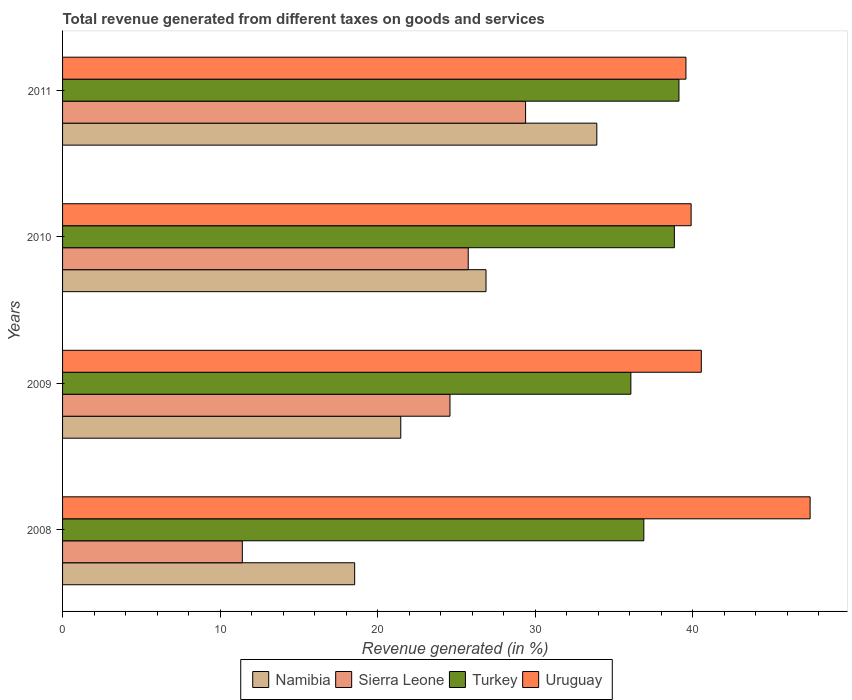How many groups of bars are there?
Make the answer very short. 4. Are the number of bars per tick equal to the number of legend labels?
Give a very brief answer. Yes. How many bars are there on the 3rd tick from the bottom?
Your answer should be very brief. 4. What is the label of the 3rd group of bars from the top?
Your answer should be very brief. 2009. In how many cases, is the number of bars for a given year not equal to the number of legend labels?
Provide a short and direct response. 0. What is the total revenue generated in Turkey in 2011?
Ensure brevity in your answer.  39.13. Across all years, what is the maximum total revenue generated in Uruguay?
Provide a succinct answer. 47.45. Across all years, what is the minimum total revenue generated in Sierra Leone?
Ensure brevity in your answer.  11.41. In which year was the total revenue generated in Sierra Leone minimum?
Your answer should be very brief. 2008. What is the total total revenue generated in Turkey in the graph?
Make the answer very short. 150.93. What is the difference between the total revenue generated in Sierra Leone in 2008 and that in 2010?
Keep it short and to the point. -14.34. What is the difference between the total revenue generated in Turkey in 2011 and the total revenue generated in Sierra Leone in 2008?
Your answer should be compact. 27.72. What is the average total revenue generated in Namibia per year?
Offer a very short reply. 25.2. In the year 2010, what is the difference between the total revenue generated in Sierra Leone and total revenue generated in Turkey?
Offer a terse response. -13.08. What is the ratio of the total revenue generated in Namibia in 2008 to that in 2011?
Provide a short and direct response. 0.55. Is the difference between the total revenue generated in Sierra Leone in 2009 and 2011 greater than the difference between the total revenue generated in Turkey in 2009 and 2011?
Make the answer very short. No. What is the difference between the highest and the second highest total revenue generated in Turkey?
Your response must be concise. 0.29. What is the difference between the highest and the lowest total revenue generated in Namibia?
Ensure brevity in your answer.  15.37. In how many years, is the total revenue generated in Turkey greater than the average total revenue generated in Turkey taken over all years?
Provide a short and direct response. 2. Is the sum of the total revenue generated in Uruguay in 2010 and 2011 greater than the maximum total revenue generated in Sierra Leone across all years?
Offer a very short reply. Yes. Is it the case that in every year, the sum of the total revenue generated in Uruguay and total revenue generated in Sierra Leone is greater than the sum of total revenue generated in Turkey and total revenue generated in Namibia?
Provide a succinct answer. No. What does the 1st bar from the top in 2010 represents?
Give a very brief answer. Uruguay. What does the 1st bar from the bottom in 2010 represents?
Your response must be concise. Namibia. Is it the case that in every year, the sum of the total revenue generated in Uruguay and total revenue generated in Namibia is greater than the total revenue generated in Sierra Leone?
Give a very brief answer. Yes. What is the difference between two consecutive major ticks on the X-axis?
Your answer should be compact. 10. Does the graph contain any zero values?
Offer a terse response. No. Does the graph contain grids?
Your answer should be compact. No. Where does the legend appear in the graph?
Make the answer very short. Bottom center. How many legend labels are there?
Provide a short and direct response. 4. How are the legend labels stacked?
Your response must be concise. Horizontal. What is the title of the graph?
Provide a short and direct response. Total revenue generated from different taxes on goods and services. Does "Aruba" appear as one of the legend labels in the graph?
Your answer should be compact. No. What is the label or title of the X-axis?
Provide a succinct answer. Revenue generated (in %). What is the Revenue generated (in %) in Namibia in 2008?
Make the answer very short. 18.54. What is the Revenue generated (in %) of Sierra Leone in 2008?
Your response must be concise. 11.41. What is the Revenue generated (in %) of Turkey in 2008?
Your response must be concise. 36.9. What is the Revenue generated (in %) of Uruguay in 2008?
Give a very brief answer. 47.45. What is the Revenue generated (in %) in Namibia in 2009?
Offer a terse response. 21.47. What is the Revenue generated (in %) in Sierra Leone in 2009?
Make the answer very short. 24.59. What is the Revenue generated (in %) of Turkey in 2009?
Ensure brevity in your answer.  36.07. What is the Revenue generated (in %) of Uruguay in 2009?
Offer a terse response. 40.55. What is the Revenue generated (in %) of Namibia in 2010?
Offer a very short reply. 26.88. What is the Revenue generated (in %) in Sierra Leone in 2010?
Make the answer very short. 25.75. What is the Revenue generated (in %) of Turkey in 2010?
Your answer should be very brief. 38.83. What is the Revenue generated (in %) in Uruguay in 2010?
Your answer should be very brief. 39.9. What is the Revenue generated (in %) in Namibia in 2011?
Your answer should be compact. 33.91. What is the Revenue generated (in %) of Sierra Leone in 2011?
Keep it short and to the point. 29.39. What is the Revenue generated (in %) of Turkey in 2011?
Offer a very short reply. 39.13. What is the Revenue generated (in %) of Uruguay in 2011?
Your answer should be very brief. 39.57. Across all years, what is the maximum Revenue generated (in %) in Namibia?
Your answer should be very brief. 33.91. Across all years, what is the maximum Revenue generated (in %) in Sierra Leone?
Your response must be concise. 29.39. Across all years, what is the maximum Revenue generated (in %) in Turkey?
Give a very brief answer. 39.13. Across all years, what is the maximum Revenue generated (in %) of Uruguay?
Give a very brief answer. 47.45. Across all years, what is the minimum Revenue generated (in %) in Namibia?
Offer a very short reply. 18.54. Across all years, what is the minimum Revenue generated (in %) of Sierra Leone?
Keep it short and to the point. 11.41. Across all years, what is the minimum Revenue generated (in %) in Turkey?
Offer a terse response. 36.07. Across all years, what is the minimum Revenue generated (in %) in Uruguay?
Provide a short and direct response. 39.57. What is the total Revenue generated (in %) of Namibia in the graph?
Make the answer very short. 100.8. What is the total Revenue generated (in %) in Sierra Leone in the graph?
Offer a very short reply. 91.14. What is the total Revenue generated (in %) of Turkey in the graph?
Make the answer very short. 150.93. What is the total Revenue generated (in %) in Uruguay in the graph?
Make the answer very short. 167.47. What is the difference between the Revenue generated (in %) in Namibia in 2008 and that in 2009?
Offer a terse response. -2.93. What is the difference between the Revenue generated (in %) in Sierra Leone in 2008 and that in 2009?
Keep it short and to the point. -13.18. What is the difference between the Revenue generated (in %) in Turkey in 2008 and that in 2009?
Offer a very short reply. 0.82. What is the difference between the Revenue generated (in %) in Uruguay in 2008 and that in 2009?
Make the answer very short. 6.91. What is the difference between the Revenue generated (in %) of Namibia in 2008 and that in 2010?
Your answer should be very brief. -8.34. What is the difference between the Revenue generated (in %) in Sierra Leone in 2008 and that in 2010?
Ensure brevity in your answer.  -14.34. What is the difference between the Revenue generated (in %) of Turkey in 2008 and that in 2010?
Your response must be concise. -1.94. What is the difference between the Revenue generated (in %) of Uruguay in 2008 and that in 2010?
Make the answer very short. 7.55. What is the difference between the Revenue generated (in %) of Namibia in 2008 and that in 2011?
Your answer should be very brief. -15.37. What is the difference between the Revenue generated (in %) of Sierra Leone in 2008 and that in 2011?
Give a very brief answer. -17.98. What is the difference between the Revenue generated (in %) in Turkey in 2008 and that in 2011?
Your response must be concise. -2.23. What is the difference between the Revenue generated (in %) of Uruguay in 2008 and that in 2011?
Provide a short and direct response. 7.88. What is the difference between the Revenue generated (in %) in Namibia in 2009 and that in 2010?
Provide a succinct answer. -5.41. What is the difference between the Revenue generated (in %) in Sierra Leone in 2009 and that in 2010?
Your answer should be very brief. -1.16. What is the difference between the Revenue generated (in %) of Turkey in 2009 and that in 2010?
Make the answer very short. -2.76. What is the difference between the Revenue generated (in %) in Uruguay in 2009 and that in 2010?
Offer a very short reply. 0.65. What is the difference between the Revenue generated (in %) of Namibia in 2009 and that in 2011?
Ensure brevity in your answer.  -12.44. What is the difference between the Revenue generated (in %) in Sierra Leone in 2009 and that in 2011?
Your answer should be very brief. -4.8. What is the difference between the Revenue generated (in %) of Turkey in 2009 and that in 2011?
Provide a succinct answer. -3.05. What is the difference between the Revenue generated (in %) in Uruguay in 2009 and that in 2011?
Keep it short and to the point. 0.98. What is the difference between the Revenue generated (in %) of Namibia in 2010 and that in 2011?
Offer a terse response. -7.03. What is the difference between the Revenue generated (in %) in Sierra Leone in 2010 and that in 2011?
Your response must be concise. -3.64. What is the difference between the Revenue generated (in %) of Turkey in 2010 and that in 2011?
Your response must be concise. -0.29. What is the difference between the Revenue generated (in %) in Uruguay in 2010 and that in 2011?
Offer a very short reply. 0.33. What is the difference between the Revenue generated (in %) in Namibia in 2008 and the Revenue generated (in %) in Sierra Leone in 2009?
Your response must be concise. -6.05. What is the difference between the Revenue generated (in %) of Namibia in 2008 and the Revenue generated (in %) of Turkey in 2009?
Provide a short and direct response. -17.53. What is the difference between the Revenue generated (in %) in Namibia in 2008 and the Revenue generated (in %) in Uruguay in 2009?
Offer a very short reply. -22. What is the difference between the Revenue generated (in %) in Sierra Leone in 2008 and the Revenue generated (in %) in Turkey in 2009?
Provide a succinct answer. -24.66. What is the difference between the Revenue generated (in %) of Sierra Leone in 2008 and the Revenue generated (in %) of Uruguay in 2009?
Provide a succinct answer. -29.13. What is the difference between the Revenue generated (in %) in Turkey in 2008 and the Revenue generated (in %) in Uruguay in 2009?
Keep it short and to the point. -3.65. What is the difference between the Revenue generated (in %) of Namibia in 2008 and the Revenue generated (in %) of Sierra Leone in 2010?
Give a very brief answer. -7.21. What is the difference between the Revenue generated (in %) in Namibia in 2008 and the Revenue generated (in %) in Turkey in 2010?
Your answer should be compact. -20.29. What is the difference between the Revenue generated (in %) in Namibia in 2008 and the Revenue generated (in %) in Uruguay in 2010?
Offer a terse response. -21.36. What is the difference between the Revenue generated (in %) in Sierra Leone in 2008 and the Revenue generated (in %) in Turkey in 2010?
Provide a succinct answer. -27.42. What is the difference between the Revenue generated (in %) of Sierra Leone in 2008 and the Revenue generated (in %) of Uruguay in 2010?
Make the answer very short. -28.49. What is the difference between the Revenue generated (in %) of Turkey in 2008 and the Revenue generated (in %) of Uruguay in 2010?
Keep it short and to the point. -3. What is the difference between the Revenue generated (in %) of Namibia in 2008 and the Revenue generated (in %) of Sierra Leone in 2011?
Provide a succinct answer. -10.85. What is the difference between the Revenue generated (in %) in Namibia in 2008 and the Revenue generated (in %) in Turkey in 2011?
Your answer should be very brief. -20.58. What is the difference between the Revenue generated (in %) of Namibia in 2008 and the Revenue generated (in %) of Uruguay in 2011?
Offer a very short reply. -21.03. What is the difference between the Revenue generated (in %) of Sierra Leone in 2008 and the Revenue generated (in %) of Turkey in 2011?
Your answer should be very brief. -27.72. What is the difference between the Revenue generated (in %) of Sierra Leone in 2008 and the Revenue generated (in %) of Uruguay in 2011?
Offer a terse response. -28.16. What is the difference between the Revenue generated (in %) in Turkey in 2008 and the Revenue generated (in %) in Uruguay in 2011?
Your answer should be very brief. -2.67. What is the difference between the Revenue generated (in %) in Namibia in 2009 and the Revenue generated (in %) in Sierra Leone in 2010?
Offer a very short reply. -4.28. What is the difference between the Revenue generated (in %) in Namibia in 2009 and the Revenue generated (in %) in Turkey in 2010?
Provide a short and direct response. -17.37. What is the difference between the Revenue generated (in %) of Namibia in 2009 and the Revenue generated (in %) of Uruguay in 2010?
Offer a very short reply. -18.43. What is the difference between the Revenue generated (in %) of Sierra Leone in 2009 and the Revenue generated (in %) of Turkey in 2010?
Make the answer very short. -14.24. What is the difference between the Revenue generated (in %) of Sierra Leone in 2009 and the Revenue generated (in %) of Uruguay in 2010?
Keep it short and to the point. -15.31. What is the difference between the Revenue generated (in %) of Turkey in 2009 and the Revenue generated (in %) of Uruguay in 2010?
Make the answer very short. -3.83. What is the difference between the Revenue generated (in %) in Namibia in 2009 and the Revenue generated (in %) in Sierra Leone in 2011?
Keep it short and to the point. -7.92. What is the difference between the Revenue generated (in %) of Namibia in 2009 and the Revenue generated (in %) of Turkey in 2011?
Provide a succinct answer. -17.66. What is the difference between the Revenue generated (in %) of Namibia in 2009 and the Revenue generated (in %) of Uruguay in 2011?
Offer a terse response. -18.1. What is the difference between the Revenue generated (in %) in Sierra Leone in 2009 and the Revenue generated (in %) in Turkey in 2011?
Your response must be concise. -14.54. What is the difference between the Revenue generated (in %) of Sierra Leone in 2009 and the Revenue generated (in %) of Uruguay in 2011?
Provide a succinct answer. -14.98. What is the difference between the Revenue generated (in %) of Turkey in 2009 and the Revenue generated (in %) of Uruguay in 2011?
Provide a short and direct response. -3.5. What is the difference between the Revenue generated (in %) of Namibia in 2010 and the Revenue generated (in %) of Sierra Leone in 2011?
Give a very brief answer. -2.51. What is the difference between the Revenue generated (in %) of Namibia in 2010 and the Revenue generated (in %) of Turkey in 2011?
Offer a terse response. -12.25. What is the difference between the Revenue generated (in %) of Namibia in 2010 and the Revenue generated (in %) of Uruguay in 2011?
Provide a short and direct response. -12.69. What is the difference between the Revenue generated (in %) of Sierra Leone in 2010 and the Revenue generated (in %) of Turkey in 2011?
Your response must be concise. -13.38. What is the difference between the Revenue generated (in %) of Sierra Leone in 2010 and the Revenue generated (in %) of Uruguay in 2011?
Provide a short and direct response. -13.82. What is the difference between the Revenue generated (in %) in Turkey in 2010 and the Revenue generated (in %) in Uruguay in 2011?
Your response must be concise. -0.74. What is the average Revenue generated (in %) of Namibia per year?
Provide a short and direct response. 25.2. What is the average Revenue generated (in %) of Sierra Leone per year?
Provide a succinct answer. 22.79. What is the average Revenue generated (in %) of Turkey per year?
Your response must be concise. 37.73. What is the average Revenue generated (in %) of Uruguay per year?
Provide a succinct answer. 41.87. In the year 2008, what is the difference between the Revenue generated (in %) of Namibia and Revenue generated (in %) of Sierra Leone?
Provide a short and direct response. 7.13. In the year 2008, what is the difference between the Revenue generated (in %) in Namibia and Revenue generated (in %) in Turkey?
Ensure brevity in your answer.  -18.35. In the year 2008, what is the difference between the Revenue generated (in %) of Namibia and Revenue generated (in %) of Uruguay?
Ensure brevity in your answer.  -28.91. In the year 2008, what is the difference between the Revenue generated (in %) of Sierra Leone and Revenue generated (in %) of Turkey?
Give a very brief answer. -25.49. In the year 2008, what is the difference between the Revenue generated (in %) of Sierra Leone and Revenue generated (in %) of Uruguay?
Your answer should be very brief. -36.04. In the year 2008, what is the difference between the Revenue generated (in %) of Turkey and Revenue generated (in %) of Uruguay?
Provide a short and direct response. -10.56. In the year 2009, what is the difference between the Revenue generated (in %) of Namibia and Revenue generated (in %) of Sierra Leone?
Provide a short and direct response. -3.12. In the year 2009, what is the difference between the Revenue generated (in %) of Namibia and Revenue generated (in %) of Turkey?
Provide a succinct answer. -14.61. In the year 2009, what is the difference between the Revenue generated (in %) of Namibia and Revenue generated (in %) of Uruguay?
Offer a terse response. -19.08. In the year 2009, what is the difference between the Revenue generated (in %) in Sierra Leone and Revenue generated (in %) in Turkey?
Your answer should be very brief. -11.48. In the year 2009, what is the difference between the Revenue generated (in %) in Sierra Leone and Revenue generated (in %) in Uruguay?
Your answer should be very brief. -15.95. In the year 2009, what is the difference between the Revenue generated (in %) of Turkey and Revenue generated (in %) of Uruguay?
Keep it short and to the point. -4.47. In the year 2010, what is the difference between the Revenue generated (in %) of Namibia and Revenue generated (in %) of Sierra Leone?
Your answer should be very brief. 1.13. In the year 2010, what is the difference between the Revenue generated (in %) of Namibia and Revenue generated (in %) of Turkey?
Keep it short and to the point. -11.96. In the year 2010, what is the difference between the Revenue generated (in %) of Namibia and Revenue generated (in %) of Uruguay?
Ensure brevity in your answer.  -13.02. In the year 2010, what is the difference between the Revenue generated (in %) of Sierra Leone and Revenue generated (in %) of Turkey?
Keep it short and to the point. -13.08. In the year 2010, what is the difference between the Revenue generated (in %) in Sierra Leone and Revenue generated (in %) in Uruguay?
Provide a short and direct response. -14.15. In the year 2010, what is the difference between the Revenue generated (in %) of Turkey and Revenue generated (in %) of Uruguay?
Offer a terse response. -1.06. In the year 2011, what is the difference between the Revenue generated (in %) in Namibia and Revenue generated (in %) in Sierra Leone?
Keep it short and to the point. 4.52. In the year 2011, what is the difference between the Revenue generated (in %) of Namibia and Revenue generated (in %) of Turkey?
Offer a terse response. -5.21. In the year 2011, what is the difference between the Revenue generated (in %) of Namibia and Revenue generated (in %) of Uruguay?
Your answer should be very brief. -5.66. In the year 2011, what is the difference between the Revenue generated (in %) in Sierra Leone and Revenue generated (in %) in Turkey?
Provide a succinct answer. -9.73. In the year 2011, what is the difference between the Revenue generated (in %) of Sierra Leone and Revenue generated (in %) of Uruguay?
Give a very brief answer. -10.18. In the year 2011, what is the difference between the Revenue generated (in %) of Turkey and Revenue generated (in %) of Uruguay?
Offer a terse response. -0.44. What is the ratio of the Revenue generated (in %) in Namibia in 2008 to that in 2009?
Your answer should be compact. 0.86. What is the ratio of the Revenue generated (in %) in Sierra Leone in 2008 to that in 2009?
Keep it short and to the point. 0.46. What is the ratio of the Revenue generated (in %) in Turkey in 2008 to that in 2009?
Your answer should be compact. 1.02. What is the ratio of the Revenue generated (in %) of Uruguay in 2008 to that in 2009?
Offer a terse response. 1.17. What is the ratio of the Revenue generated (in %) in Namibia in 2008 to that in 2010?
Give a very brief answer. 0.69. What is the ratio of the Revenue generated (in %) in Sierra Leone in 2008 to that in 2010?
Offer a very short reply. 0.44. What is the ratio of the Revenue generated (in %) of Turkey in 2008 to that in 2010?
Your answer should be very brief. 0.95. What is the ratio of the Revenue generated (in %) in Uruguay in 2008 to that in 2010?
Offer a terse response. 1.19. What is the ratio of the Revenue generated (in %) of Namibia in 2008 to that in 2011?
Your answer should be compact. 0.55. What is the ratio of the Revenue generated (in %) in Sierra Leone in 2008 to that in 2011?
Keep it short and to the point. 0.39. What is the ratio of the Revenue generated (in %) of Turkey in 2008 to that in 2011?
Keep it short and to the point. 0.94. What is the ratio of the Revenue generated (in %) in Uruguay in 2008 to that in 2011?
Ensure brevity in your answer.  1.2. What is the ratio of the Revenue generated (in %) in Namibia in 2009 to that in 2010?
Give a very brief answer. 0.8. What is the ratio of the Revenue generated (in %) in Sierra Leone in 2009 to that in 2010?
Offer a very short reply. 0.95. What is the ratio of the Revenue generated (in %) in Turkey in 2009 to that in 2010?
Provide a short and direct response. 0.93. What is the ratio of the Revenue generated (in %) of Uruguay in 2009 to that in 2010?
Ensure brevity in your answer.  1.02. What is the ratio of the Revenue generated (in %) of Namibia in 2009 to that in 2011?
Make the answer very short. 0.63. What is the ratio of the Revenue generated (in %) of Sierra Leone in 2009 to that in 2011?
Offer a very short reply. 0.84. What is the ratio of the Revenue generated (in %) of Turkey in 2009 to that in 2011?
Offer a very short reply. 0.92. What is the ratio of the Revenue generated (in %) in Uruguay in 2009 to that in 2011?
Offer a terse response. 1.02. What is the ratio of the Revenue generated (in %) in Namibia in 2010 to that in 2011?
Keep it short and to the point. 0.79. What is the ratio of the Revenue generated (in %) of Sierra Leone in 2010 to that in 2011?
Give a very brief answer. 0.88. What is the ratio of the Revenue generated (in %) of Turkey in 2010 to that in 2011?
Provide a succinct answer. 0.99. What is the ratio of the Revenue generated (in %) of Uruguay in 2010 to that in 2011?
Offer a very short reply. 1.01. What is the difference between the highest and the second highest Revenue generated (in %) in Namibia?
Your answer should be compact. 7.03. What is the difference between the highest and the second highest Revenue generated (in %) of Sierra Leone?
Make the answer very short. 3.64. What is the difference between the highest and the second highest Revenue generated (in %) of Turkey?
Offer a very short reply. 0.29. What is the difference between the highest and the second highest Revenue generated (in %) in Uruguay?
Offer a terse response. 6.91. What is the difference between the highest and the lowest Revenue generated (in %) in Namibia?
Provide a short and direct response. 15.37. What is the difference between the highest and the lowest Revenue generated (in %) in Sierra Leone?
Offer a terse response. 17.98. What is the difference between the highest and the lowest Revenue generated (in %) in Turkey?
Offer a terse response. 3.05. What is the difference between the highest and the lowest Revenue generated (in %) in Uruguay?
Provide a succinct answer. 7.88. 